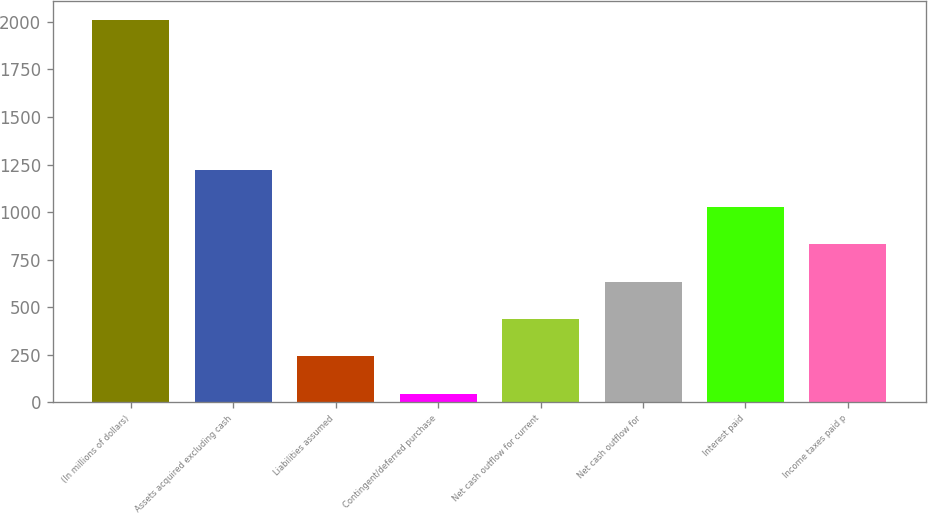<chart> <loc_0><loc_0><loc_500><loc_500><bar_chart><fcel>(In millions of dollars)<fcel>Assets acquired excluding cash<fcel>Liabilities assumed<fcel>Contingent/deferred purchase<fcel>Net cash outflow for current<fcel>Net cash outflow for<fcel>Interest paid<fcel>Income taxes paid p<nl><fcel>2008<fcel>1222.8<fcel>241.3<fcel>45<fcel>437.6<fcel>633.9<fcel>1026.5<fcel>830.2<nl></chart> 